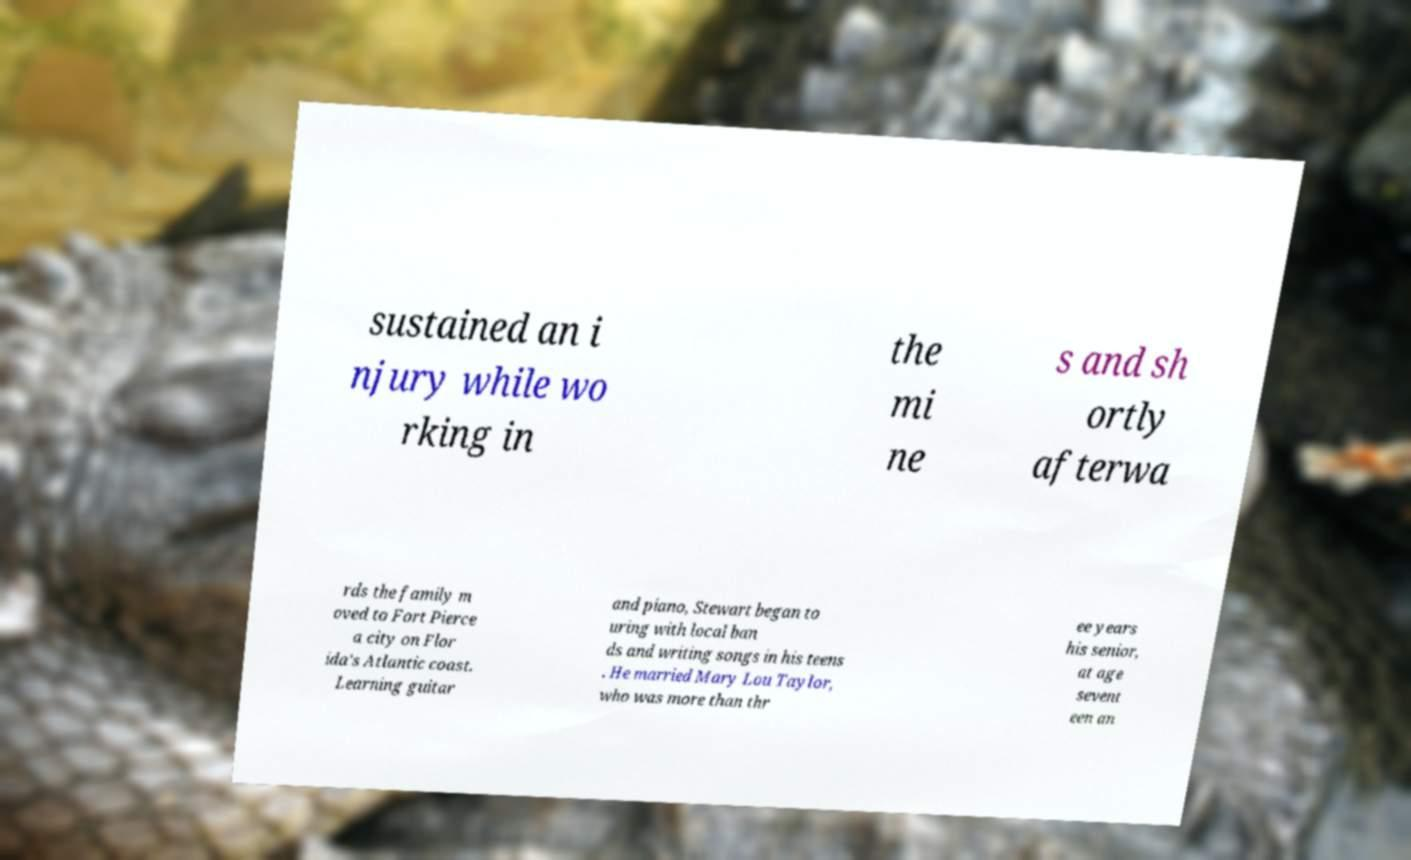What messages or text are displayed in this image? I need them in a readable, typed format. sustained an i njury while wo rking in the mi ne s and sh ortly afterwa rds the family m oved to Fort Pierce a city on Flor ida's Atlantic coast. Learning guitar and piano, Stewart began to uring with local ban ds and writing songs in his teens . He married Mary Lou Taylor, who was more than thr ee years his senior, at age sevent een an 